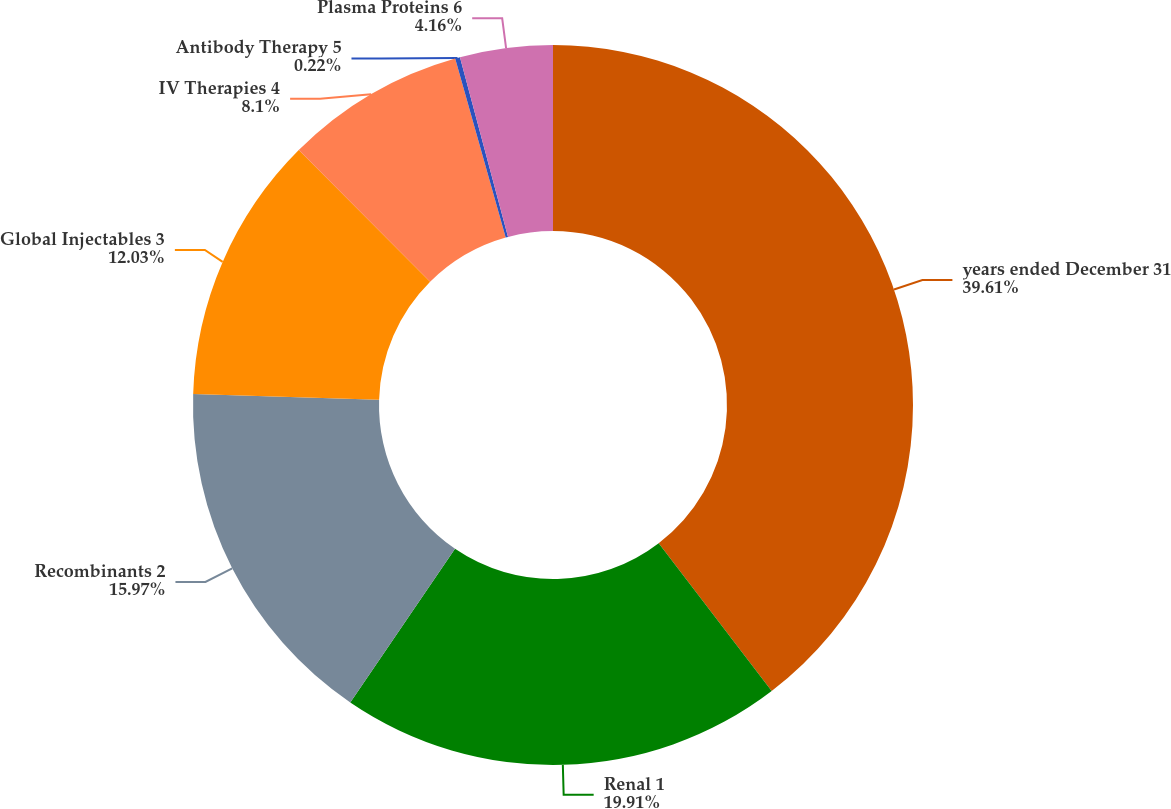<chart> <loc_0><loc_0><loc_500><loc_500><pie_chart><fcel>years ended December 31<fcel>Renal 1<fcel>Recombinants 2<fcel>Global Injectables 3<fcel>IV Therapies 4<fcel>Antibody Therapy 5<fcel>Plasma Proteins 6<nl><fcel>39.61%<fcel>19.91%<fcel>15.97%<fcel>12.03%<fcel>8.1%<fcel>0.22%<fcel>4.16%<nl></chart> 